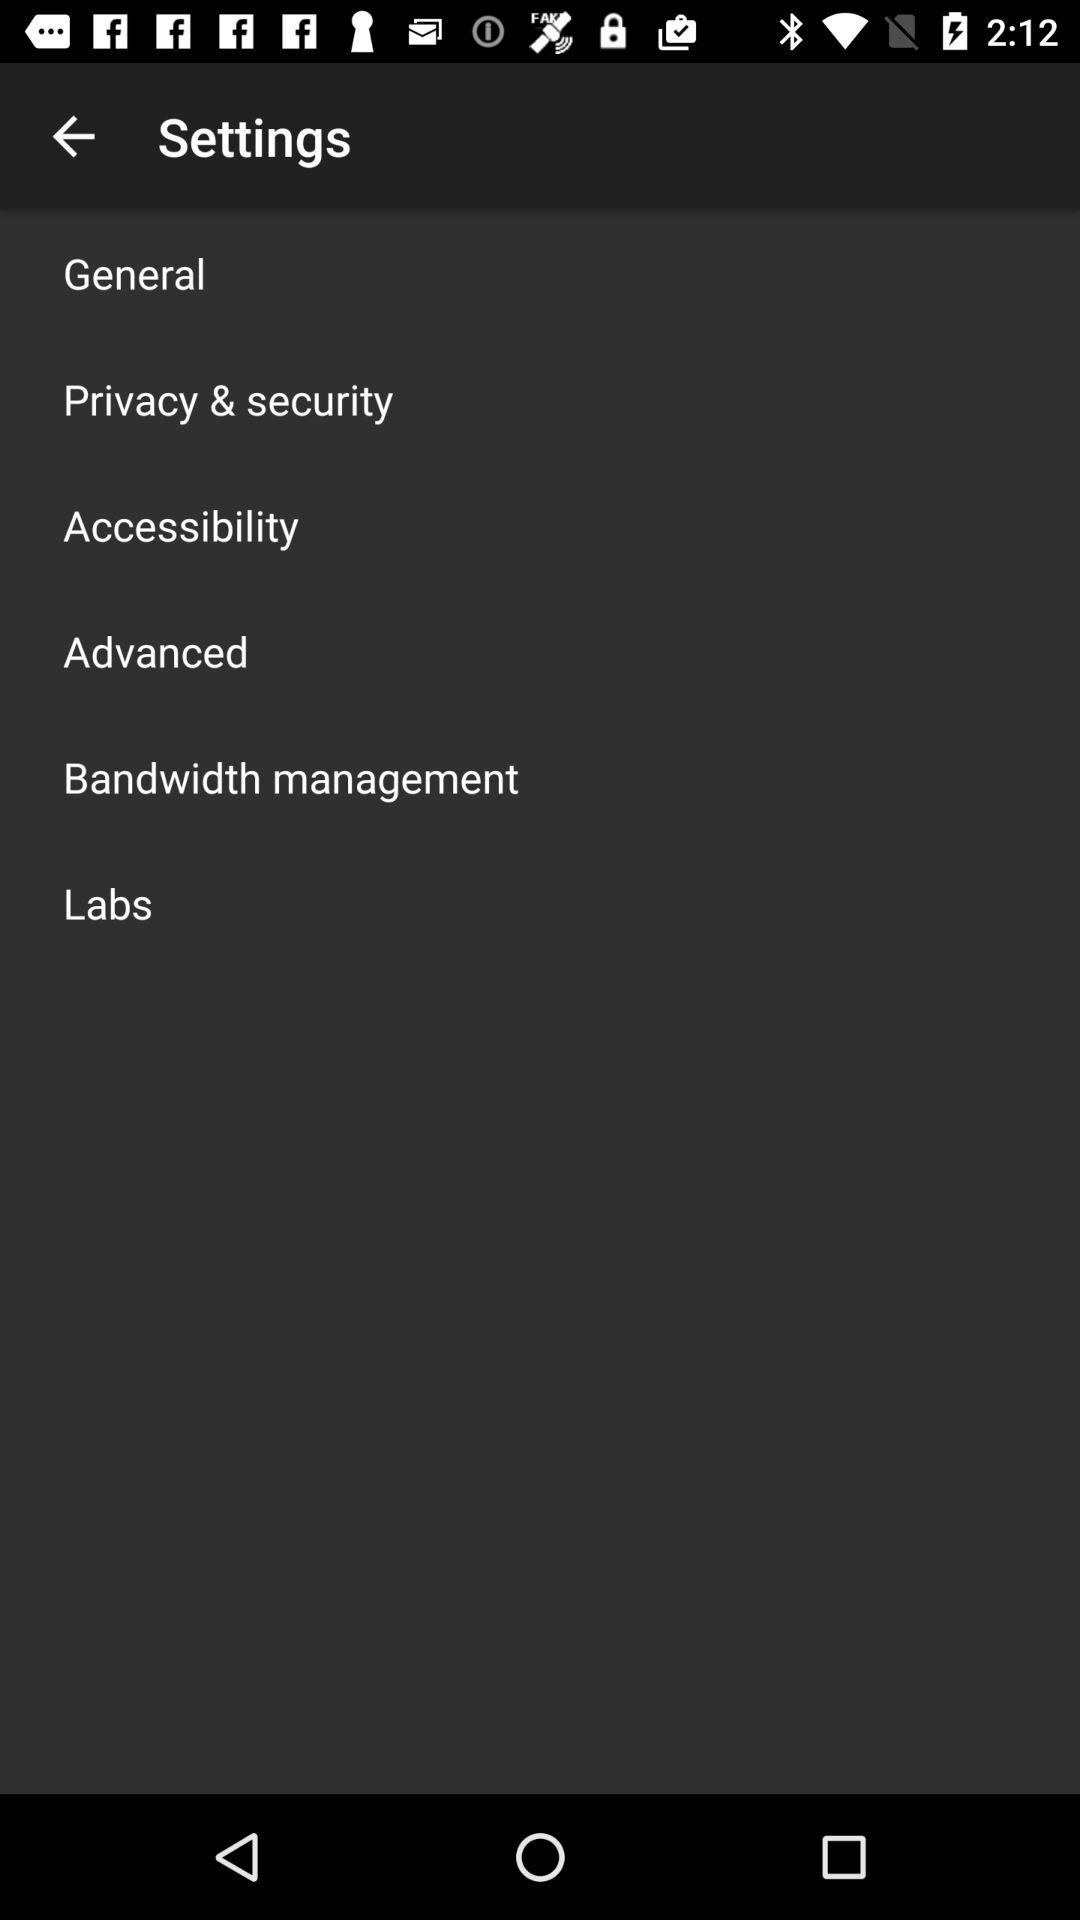How many settings are there in the settings menu?
Answer the question using a single word or phrase. 6 